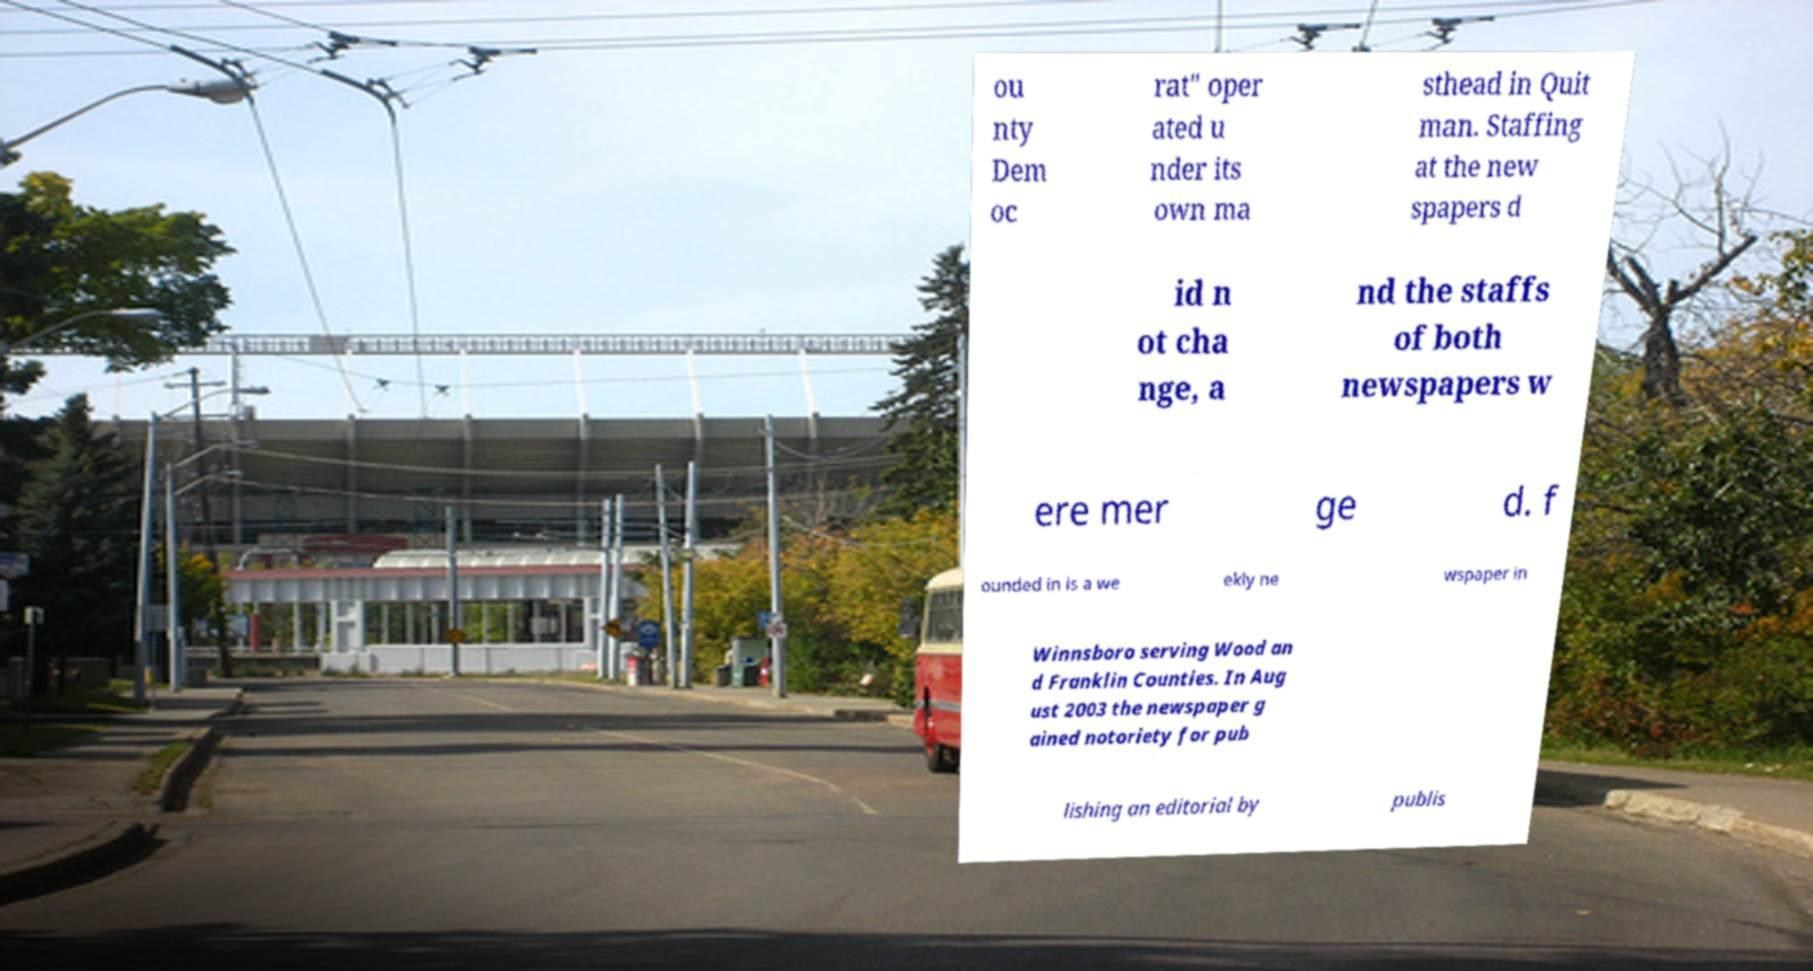Could you assist in decoding the text presented in this image and type it out clearly? ou nty Dem oc rat" oper ated u nder its own ma sthead in Quit man. Staffing at the new spapers d id n ot cha nge, a nd the staffs of both newspapers w ere mer ge d. f ounded in is a we ekly ne wspaper in Winnsboro serving Wood an d Franklin Counties. In Aug ust 2003 the newspaper g ained notoriety for pub lishing an editorial by publis 